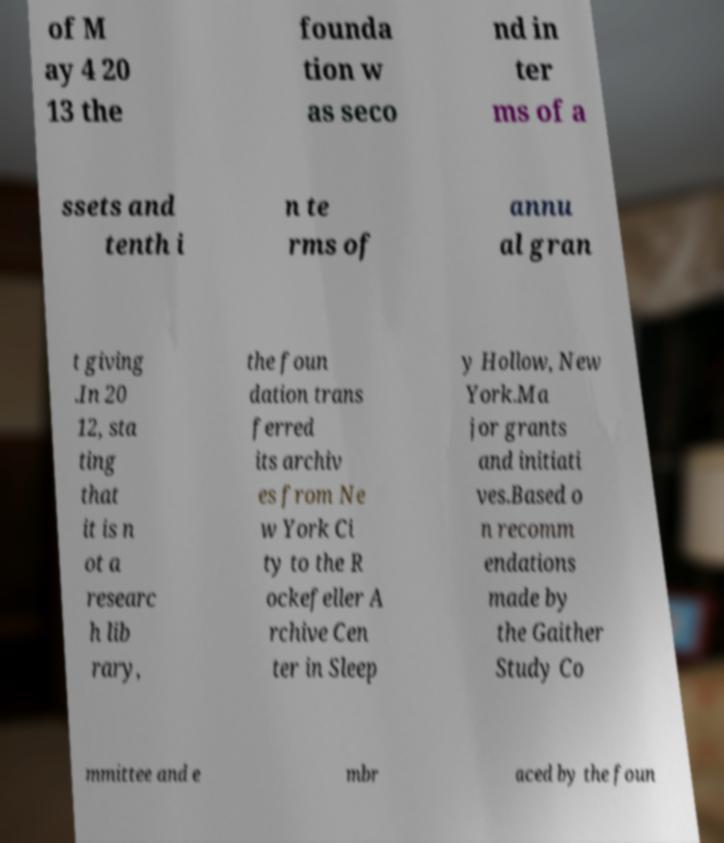I need the written content from this picture converted into text. Can you do that? of M ay 4 20 13 the founda tion w as seco nd in ter ms of a ssets and tenth i n te rms of annu al gran t giving .In 20 12, sta ting that it is n ot a researc h lib rary, the foun dation trans ferred its archiv es from Ne w York Ci ty to the R ockefeller A rchive Cen ter in Sleep y Hollow, New York.Ma jor grants and initiati ves.Based o n recomm endations made by the Gaither Study Co mmittee and e mbr aced by the foun 